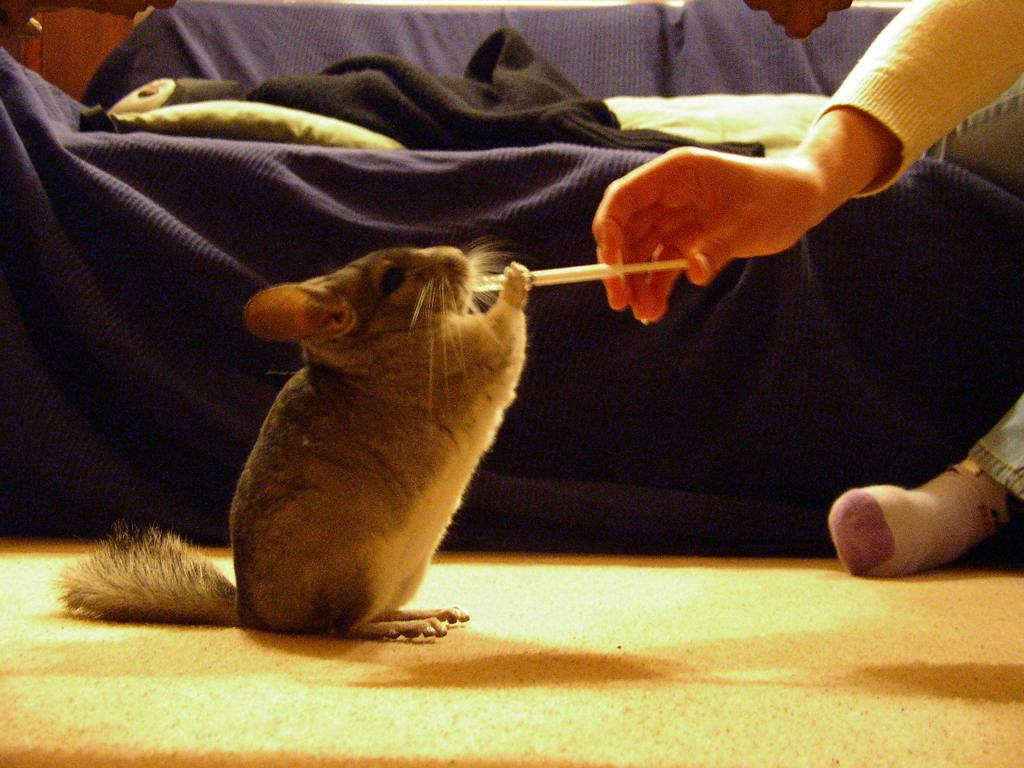What animal is the main subject of the picture? The main subject of the picture is a rat. What is the rat doing in the image? The rat is sitting and holding an object. Who is giving the object to the rat? A man is giving the object to the rat. What can be seen in the background of the picture? There is a couch in the background of the picture. What type of thread is the rat using to sew a duck in the image? There is no thread, duck, or sewing activity present in the image. 